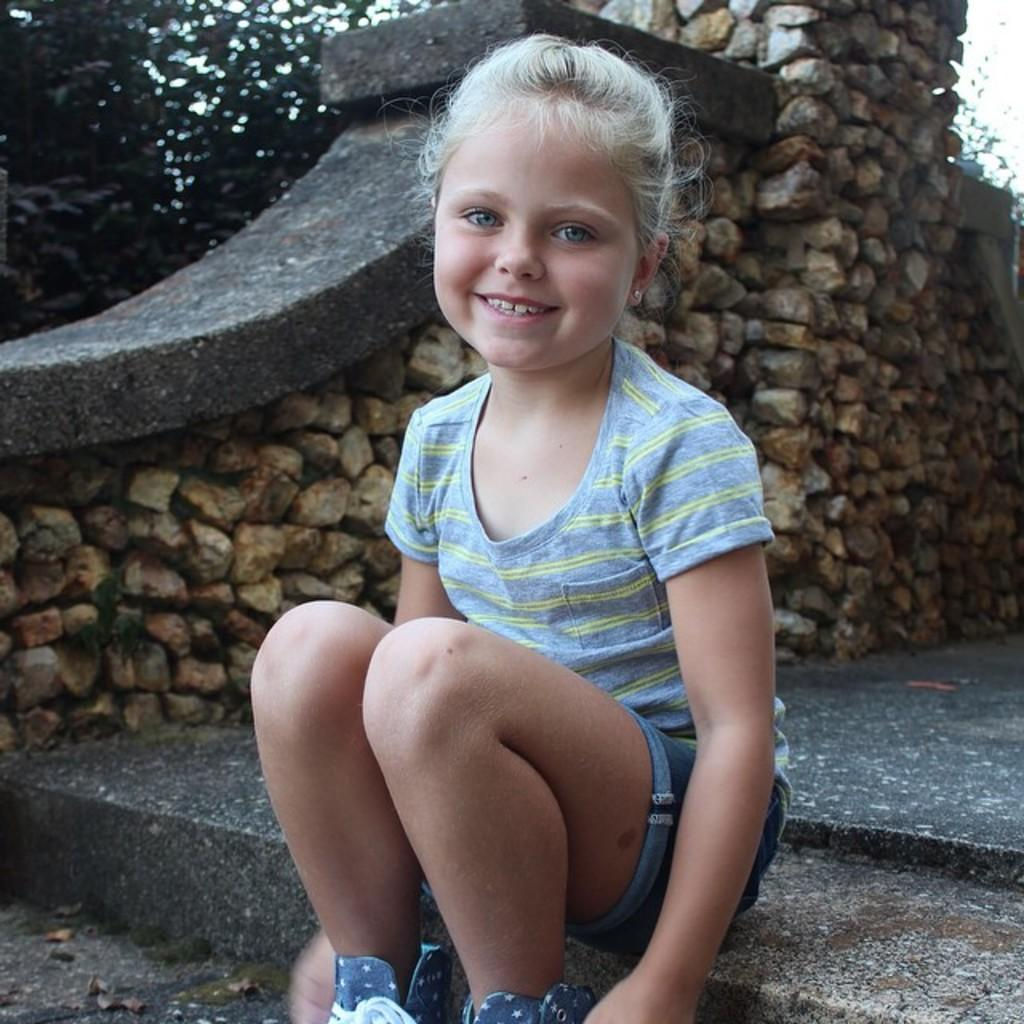What is the girl in the image doing? The girl is sitting in the image. What is the girl's facial expression? The girl is smiling. What can be seen in the background of the image? There is a wall built with rocks and a tree visible in the background. How much payment does the girl receive for her performance in the image? There is no indication in the image that the girl is performing or receiving any payment. 